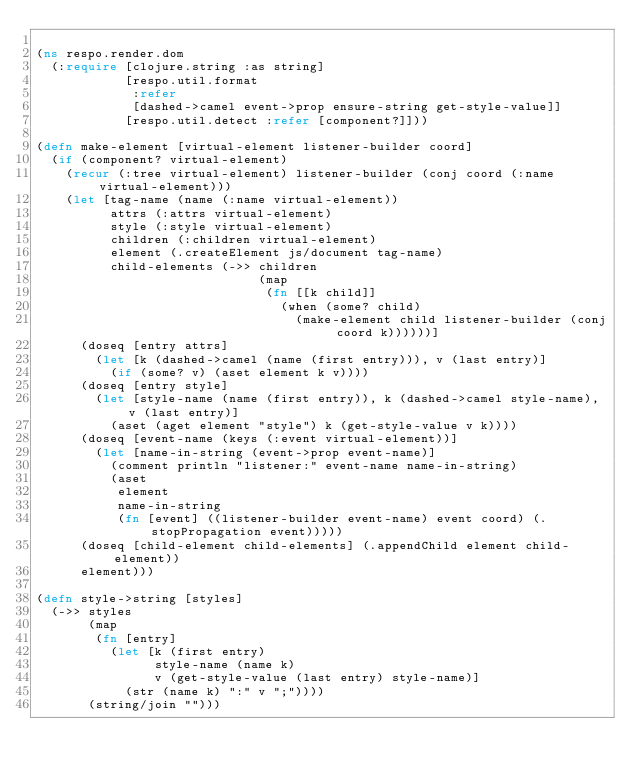<code> <loc_0><loc_0><loc_500><loc_500><_Clojure_>
(ns respo.render.dom
  (:require [clojure.string :as string]
            [respo.util.format
             :refer
             [dashed->camel event->prop ensure-string get-style-value]]
            [respo.util.detect :refer [component?]]))

(defn make-element [virtual-element listener-builder coord]
  (if (component? virtual-element)
    (recur (:tree virtual-element) listener-builder (conj coord (:name virtual-element)))
    (let [tag-name (name (:name virtual-element))
          attrs (:attrs virtual-element)
          style (:style virtual-element)
          children (:children virtual-element)
          element (.createElement js/document tag-name)
          child-elements (->> children
                              (map
                               (fn [[k child]]
                                 (when (some? child)
                                   (make-element child listener-builder (conj coord k))))))]
      (doseq [entry attrs]
        (let [k (dashed->camel (name (first entry))), v (last entry)]
          (if (some? v) (aset element k v))))
      (doseq [entry style]
        (let [style-name (name (first entry)), k (dashed->camel style-name), v (last entry)]
          (aset (aget element "style") k (get-style-value v k))))
      (doseq [event-name (keys (:event virtual-element))]
        (let [name-in-string (event->prop event-name)]
          (comment println "listener:" event-name name-in-string)
          (aset
           element
           name-in-string
           (fn [event] ((listener-builder event-name) event coord) (.stopPropagation event)))))
      (doseq [child-element child-elements] (.appendChild element child-element))
      element)))

(defn style->string [styles]
  (->> styles
       (map
        (fn [entry]
          (let [k (first entry)
                style-name (name k)
                v (get-style-value (last entry) style-name)]
            (str (name k) ":" v ";"))))
       (string/join "")))
</code> 